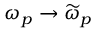Convert formula to latex. <formula><loc_0><loc_0><loc_500><loc_500>\omega _ { p } \rightarrow \widetilde { \omega } _ { p }</formula> 